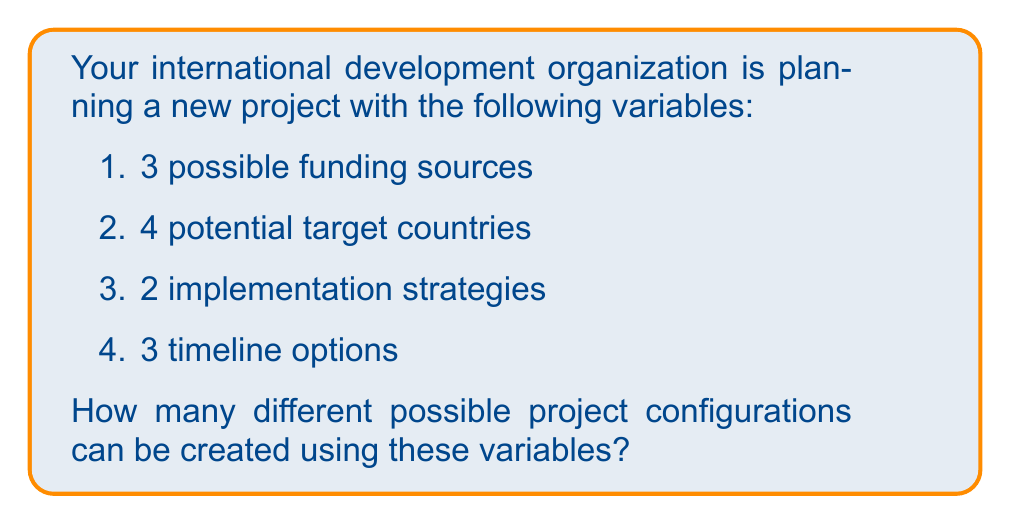Give your solution to this math problem. To solve this problem, we'll use the multiplication principle of counting. This principle states that if we have a series of independent choices, the total number of possible outcomes is the product of the number of options for each choice.

Let's break down the problem step-by-step:

1. Funding sources: 3 options
2. Target countries: 4 options
3. Implementation strategies: 2 options
4. Timeline options: 3 options

To calculate the total number of possible project configurations:

$$ \text{Total configurations} = 3 \times 4 \times 2 \times 3 $$

$$ = 72 $$

This means that for each funding source, we have 4 country options. For each of these combinations, we have 2 implementation strategies, and for each of those, we have 3 timeline options.

The multiplication principle allows us to consider all possible combinations of these independent choices, resulting in the total number of unique project configurations.
Answer: 72 